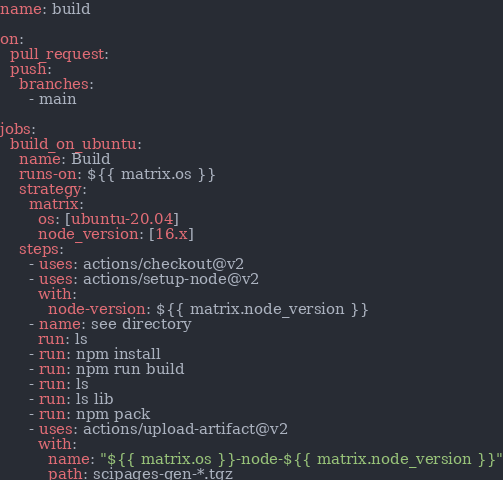<code> <loc_0><loc_0><loc_500><loc_500><_YAML_>name: build

on:
  pull_request:
  push:
    branches:
      - main

jobs:
  build_on_ubuntu:
    name: Build
    runs-on: ${{ matrix.os }}
    strategy:
      matrix:
        os: [ubuntu-20.04]
        node_version: [16.x]
    steps:
      - uses: actions/checkout@v2
      - uses: actions/setup-node@v2
        with:
          node-version: ${{ matrix.node_version }}
      - name: see directory
        run: ls
      - run: npm install
      - run: npm run build
      - run: ls
      - run: ls lib
      - run: npm pack
      - uses: actions/upload-artifact@v2
        with:
          name: "${{ matrix.os }}-node-${{ matrix.node_version }}"
          path: scipages-gen-*.tgz
</code> 